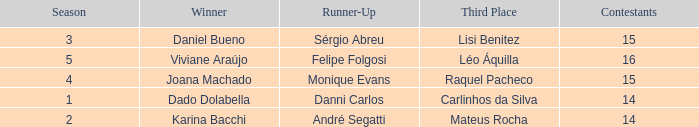How many contestants were there when the runner-up was Monique Evans? 15.0. 